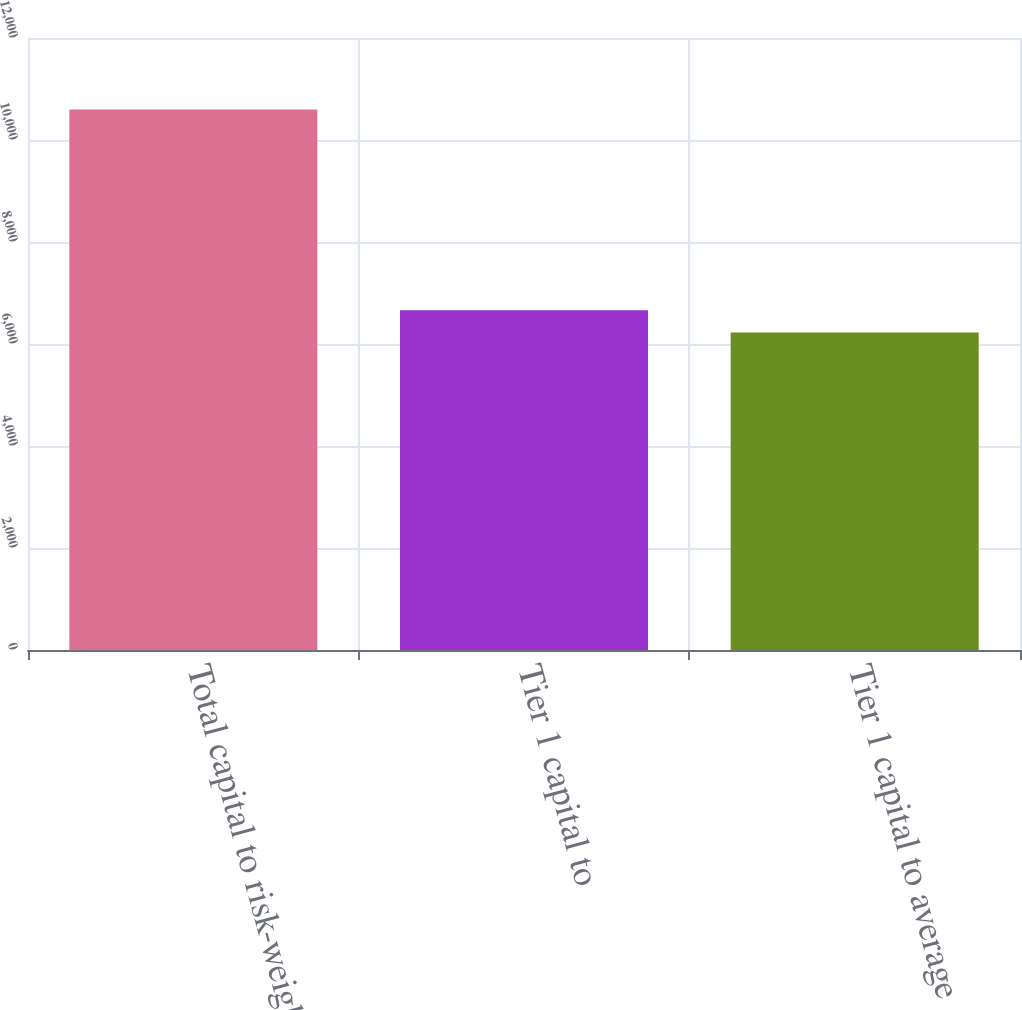Convert chart. <chart><loc_0><loc_0><loc_500><loc_500><bar_chart><fcel>Total capital to risk-weighted<fcel>Tier 1 capital to<fcel>Tier 1 capital to average<nl><fcel>10596<fcel>6663.9<fcel>6227<nl></chart> 